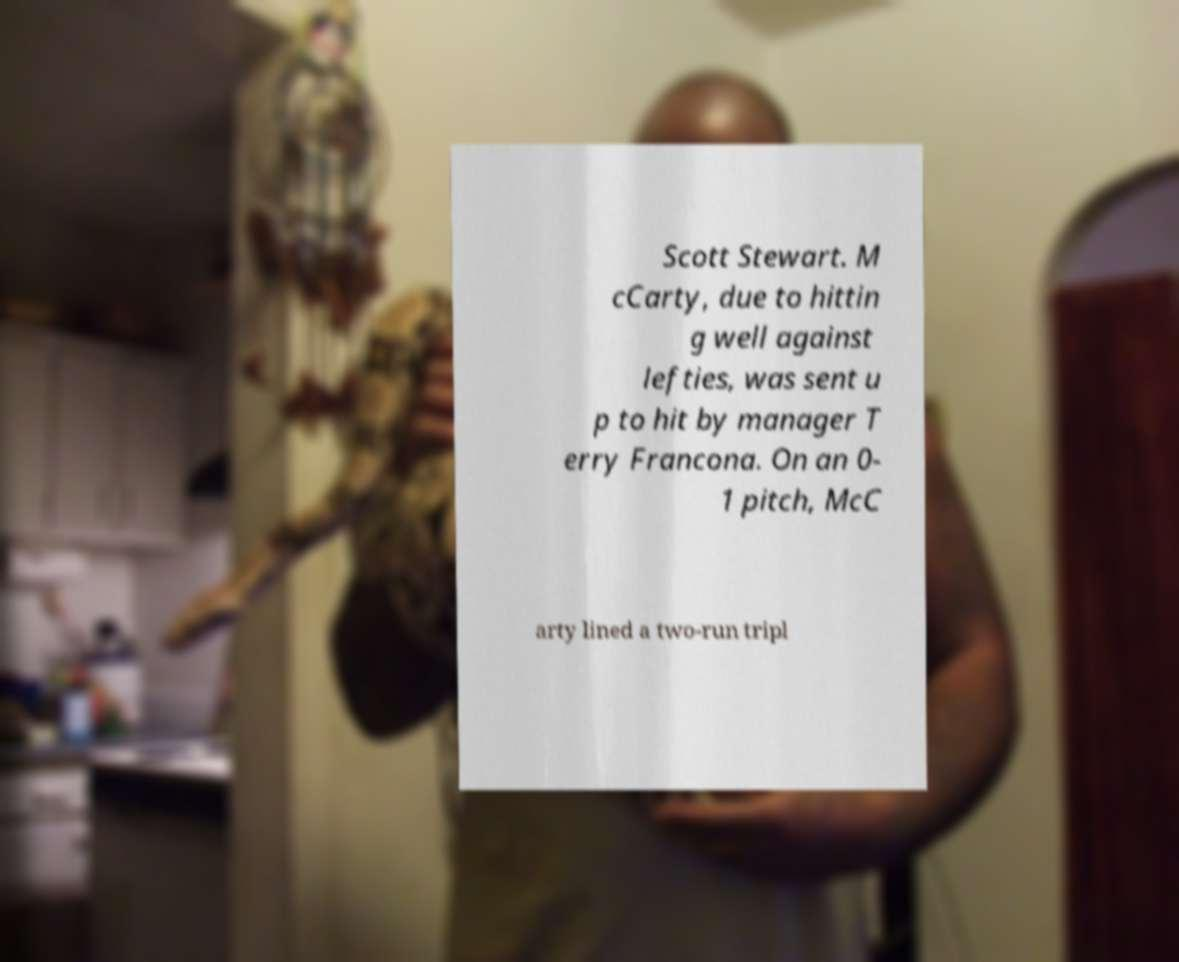Please identify and transcribe the text found in this image. Scott Stewart. M cCarty, due to hittin g well against lefties, was sent u p to hit by manager T erry Francona. On an 0- 1 pitch, McC arty lined a two-run tripl 